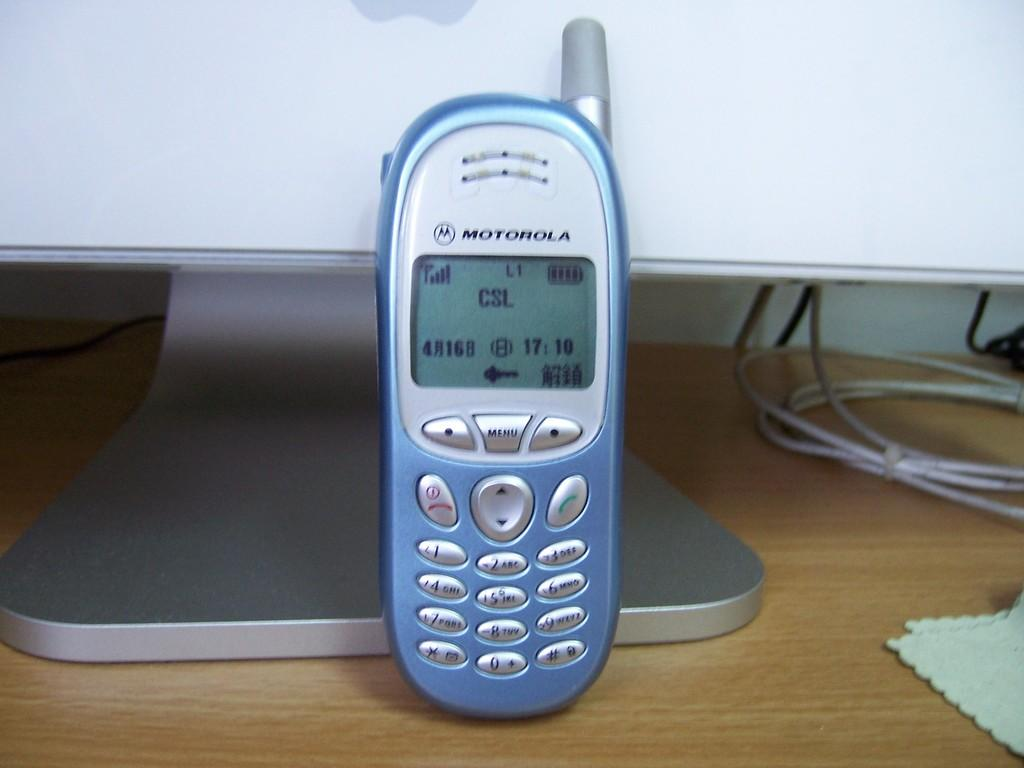<image>
Describe the image concisely. a blue, old fashioned mobile phone with csl on the screen 